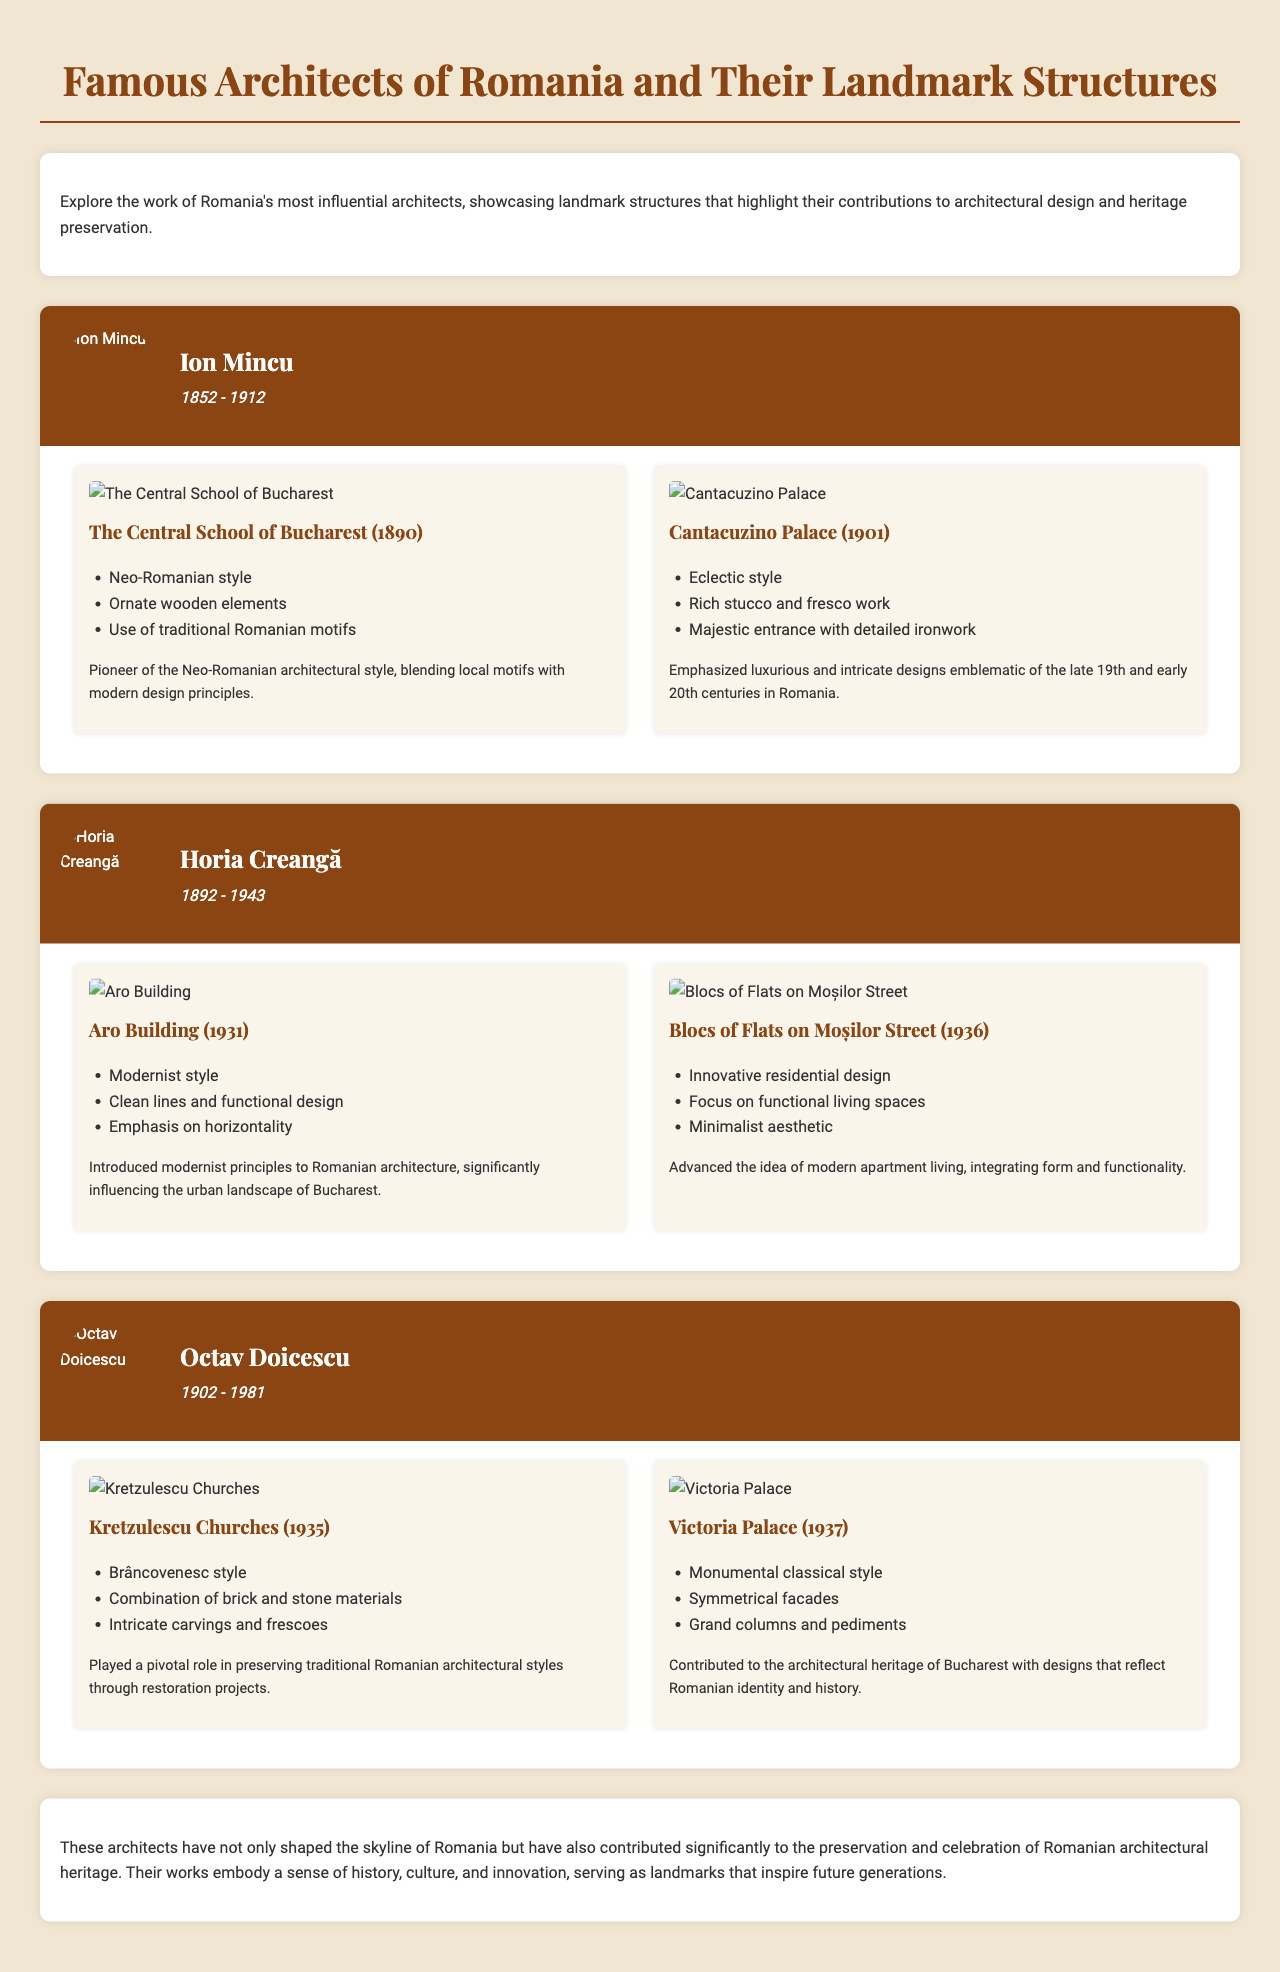What is the title of the infographic? The title appears at the top of the document and summarizes the content presented.
Answer: Famous Architects of Romania and Their Landmark Structures Who is the architect associated with the Central School of Bucharest? The architect's name is listed above the description of the school, indicating his role in its design.
Answer: Ion Mincu What year was the Aro Building completed? The completion year is stated directly under the title of the Aro Building within the architect's section.
Answer: 1931 Which architectural style is associated with Kretzulescu Churches? The style is mentioned as a key feature of the building's design within the work's details.
Answer: Brâncovenesc style How many architects are featured in the infographic? Each architect's section indicates that they are separate entries in the document, showing the number of prominent figures discussed.
Answer: Three What are the main design elements highlighted for the Cantacuzino Palace? The answer combines features that describe the structure's characteristics as listed under its title.
Answer: Rich stucco and fresco work In what year was Ion Mincu born? The birth date is found beneath his name in the document, providing a quick reference to his lifespan.
Answer: 1852 Which architect focused on modernist principles? The information about this architect's contributions to modern architecture is explicitly mentioned in their section.
Answer: Horia Creangă Name one of the key contributions of Octav Doicescu. The contributions outlined for this architect describe their impact on architectural styles within Romania.
Answer: Preserving traditional Romanian architectural styles 